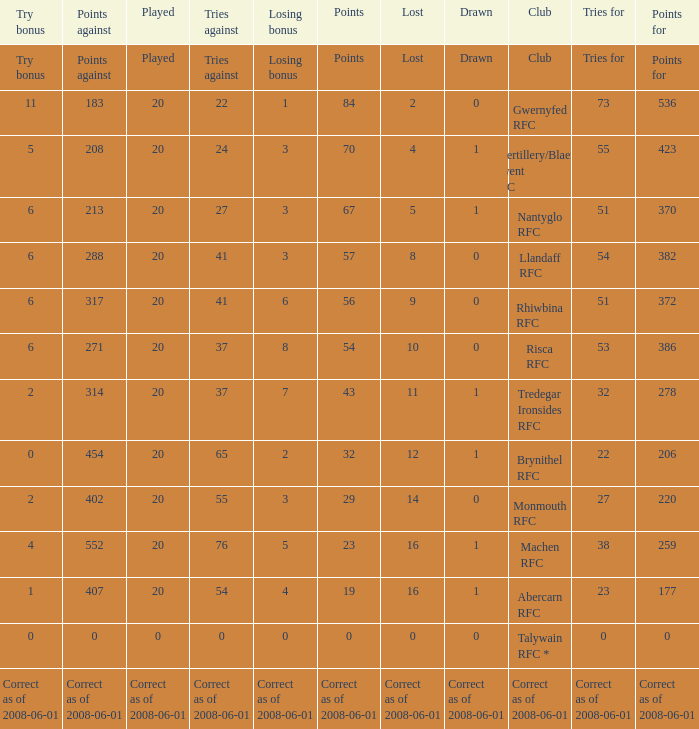If the points were 0, what were the tries for? 0.0. 